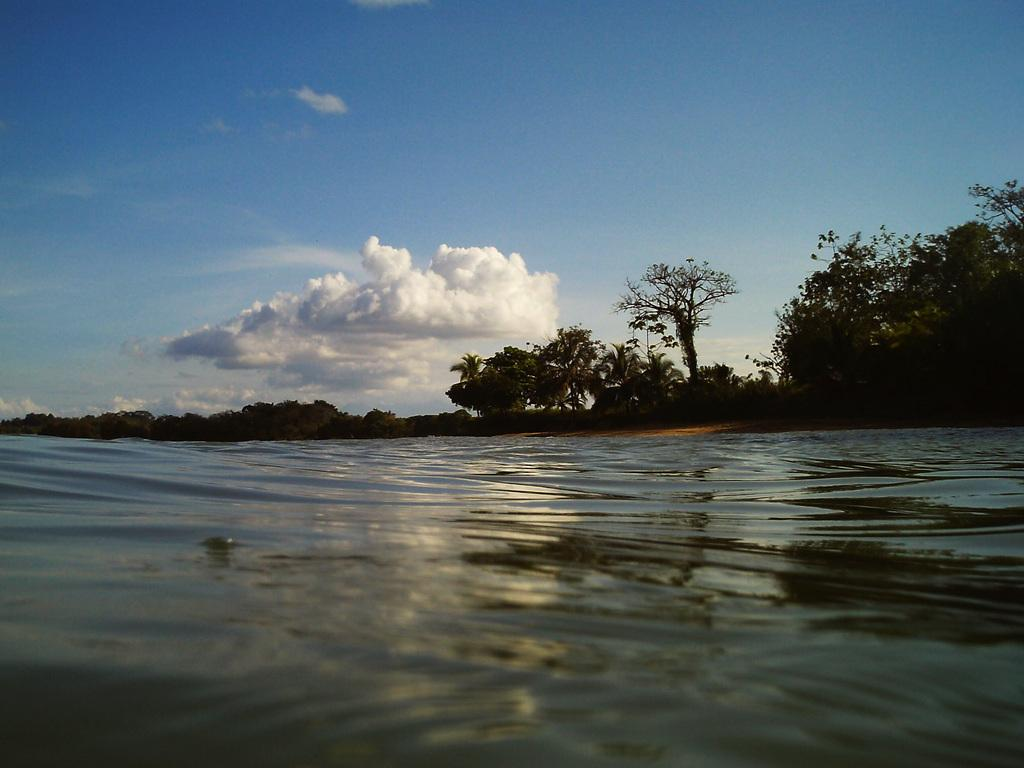What type of vegetation can be seen in the image? There are trees in the image. What natural element is visible in the image besides the trees? There is water visible in the image. How would you describe the sky in the image? The sky is blue and cloudy in the image. What type of powder can be seen falling from the sky in the image? There is no powder falling from the sky in the image; the sky is blue and cloudy. 